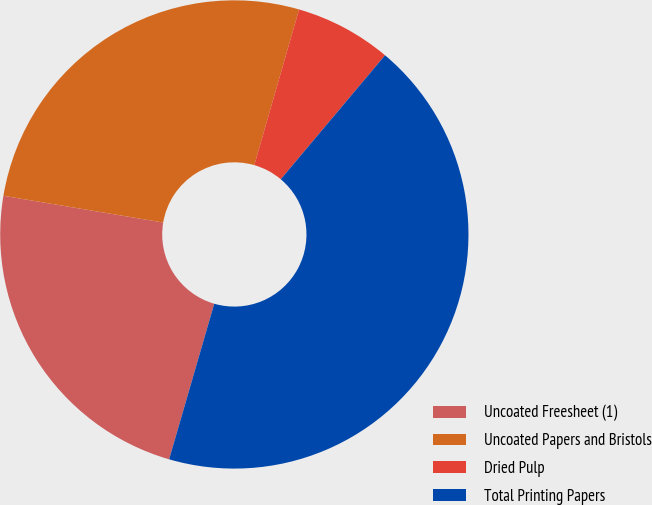Convert chart to OTSL. <chart><loc_0><loc_0><loc_500><loc_500><pie_chart><fcel>Uncoated Freesheet (1)<fcel>Uncoated Papers and Bristols<fcel>Dried Pulp<fcel>Total Printing Papers<nl><fcel>23.15%<fcel>26.82%<fcel>6.67%<fcel>43.36%<nl></chart> 